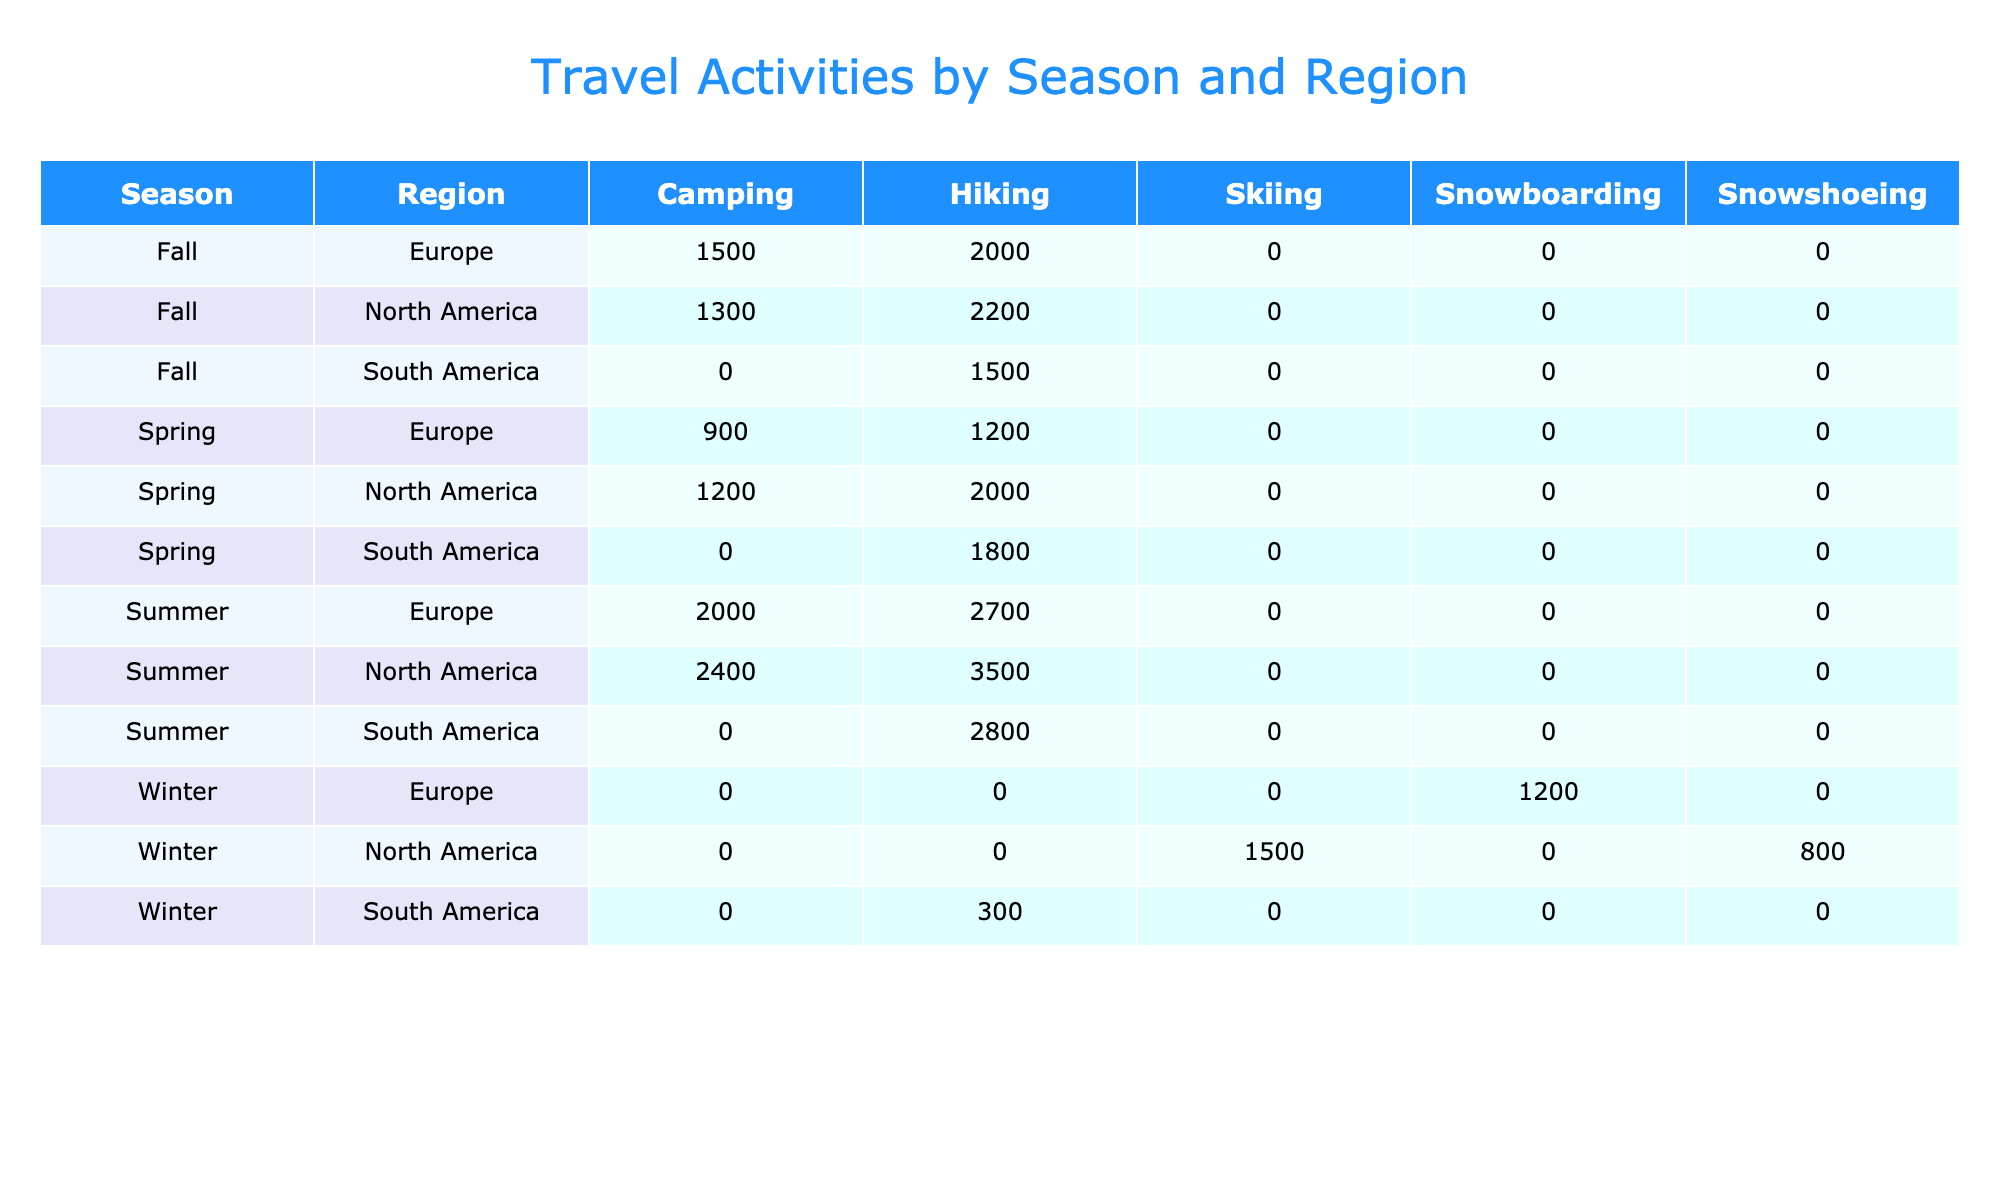What is the total frequency of hiking activities in Summer across all regions? For Summer, the hiking frequencies are: North America: 3500, South America: 2800, Europe: 2700. Summing these together: 3500 + 2800 + 2700 = 9000.
Answer: 9000 Which region has the highest frequency of camping in Spring? In Spring, the camping frequencies are: North America: 1200, South America: 0 (not listed), Europe: 900. The highest frequency is 1200 in North America.
Answer: North America Is skiing more popular than snowboarding in Winter? The frequency for skiing in Winter is 1500 and for snowboarding, it is 1200. Since 1500 is greater than 1200, skiing is indeed more popular.
Answer: Yes What is the average frequency of hiking activities in Fall? In Fall, the hiking frequencies are: North America: 2200, South America: 1500, Europe: 2000. The sum is 2200 + 1500 + 2000 = 5700. There are 3 data points, so the average is 5700/3 = 1900.
Answer: 1900 During which season is camping the most frequent in Europe? In Europe, the camping frequencies by season are: Winter: 0 (not listed), Spring: 900, Summer: 2000, Fall: 1500. The highest camping frequency is 2000 in Summer.
Answer: Summer How many activities have a frequency of over 2000 in Summer? The activities in Summer with frequencies over 2000 are hiking (3500) and camping (2400). Thus, there are two activities that exceed 2000.
Answer: 2 In which region does hiking have the lowest frequency during Winter? In Winter, the hiking frequencies per region are: North America: 0 (not listed), South America: 300, Europe: 0 (not listed). Therefore, the lowest hiking frequency is 300 in South America.
Answer: South America What is the difference in camping activity frequency between North America and Europe in Fall? In Fall, North America has a camping frequency of 1300 and Europe has 1500. The difference is 1500 - 1300 = 200.
Answer: 200 Which season has the highest total frequency across all activities in South America? In South America, the frequencies for each season are: Winter: 300, Spring: 1800, Summer: 2800, Fall: 1500. The total frequencies are 300 + 1800 + 2800 + 1500 = 6400 for Summer, which is the highest.
Answer: Summer 